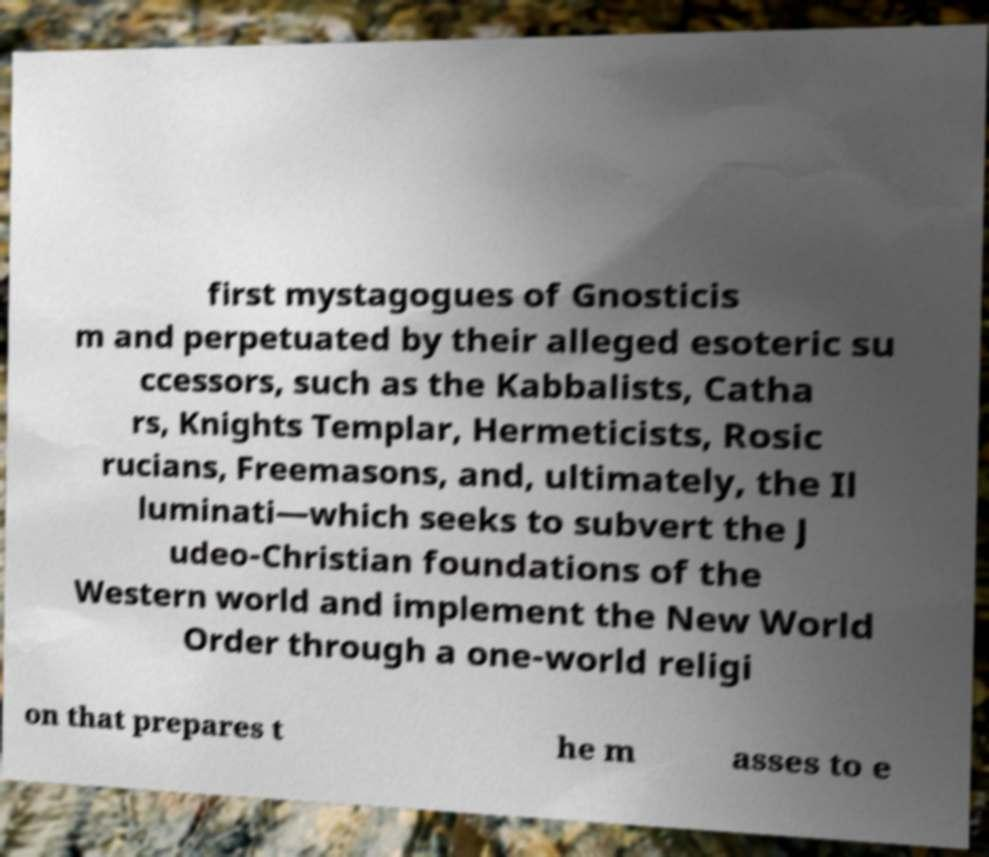I need the written content from this picture converted into text. Can you do that? first mystagogues of Gnosticis m and perpetuated by their alleged esoteric su ccessors, such as the Kabbalists, Catha rs, Knights Templar, Hermeticists, Rosic rucians, Freemasons, and, ultimately, the Il luminati—which seeks to subvert the J udeo-Christian foundations of the Western world and implement the New World Order through a one-world religi on that prepares t he m asses to e 